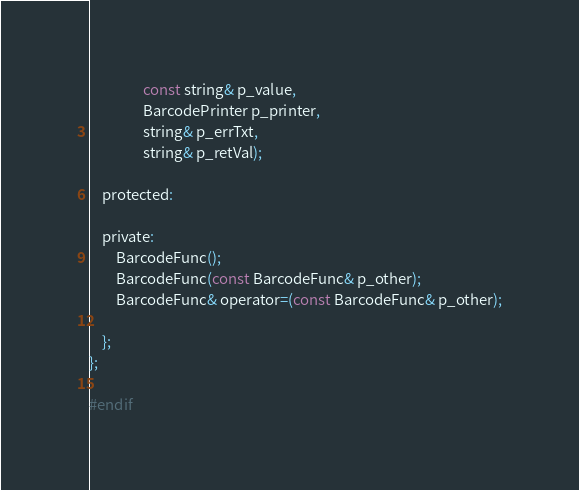<code> <loc_0><loc_0><loc_500><loc_500><_C_>                const string& p_value,
                BarcodePrinter p_printer,
                string& p_errTxt,
                string& p_retVal);

    protected:

    private:
        BarcodeFunc();
        BarcodeFunc(const BarcodeFunc& p_other);
        BarcodeFunc& operator=(const BarcodeFunc& p_other);

    };
};

#endif</code> 